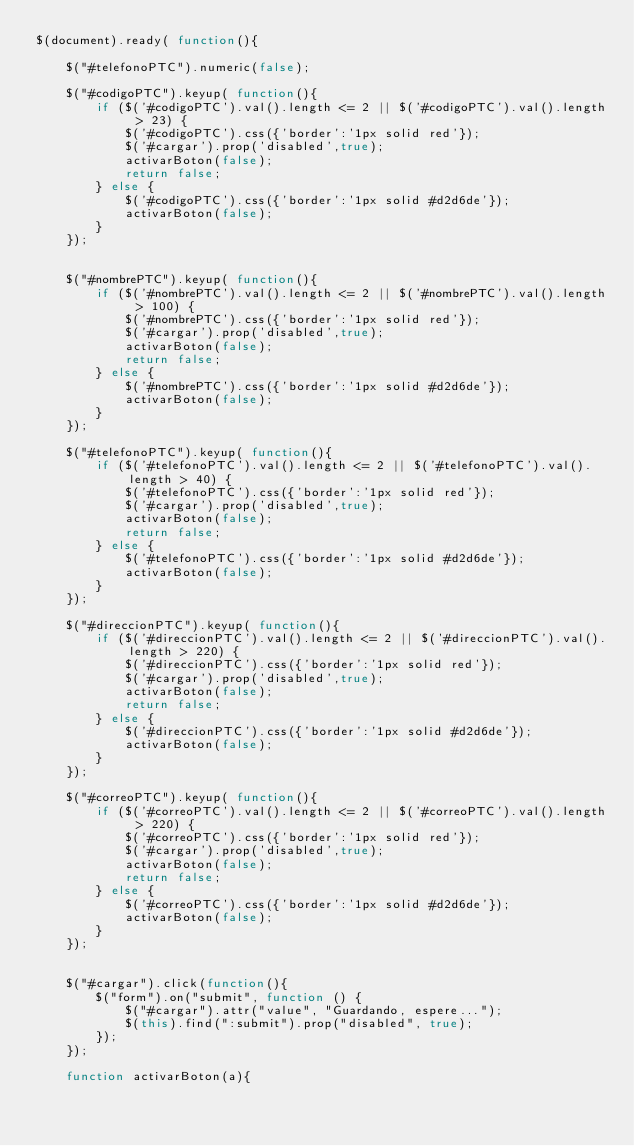Convert code to text. <code><loc_0><loc_0><loc_500><loc_500><_JavaScript_>$(document).ready( function(){

    $("#telefonoPTC").numeric(false);

    $("#codigoPTC").keyup( function(){
        if ($('#codigoPTC').val().length <= 2 || $('#codigoPTC').val().length > 23) {
            $('#codigoPTC').css({'border':'1px solid red'});
            $('#cargar').prop('disabled',true);
            activarBoton(false);
            return false;
        } else {
            $('#codigoPTC').css({'border':'1px solid #d2d6de'});
            activarBoton(false);
        }
    });


    $("#nombrePTC").keyup( function(){
        if ($('#nombrePTC').val().length <= 2 || $('#nombrePTC').val().length > 100) {
            $('#nombrePTC').css({'border':'1px solid red'});
            $('#cargar').prop('disabled',true);
            activarBoton(false);
            return false;
        } else {
            $('#nombrePTC').css({'border':'1px solid #d2d6de'});
            activarBoton(false);
        }
    });

    $("#telefonoPTC").keyup( function(){
        if ($('#telefonoPTC').val().length <= 2 || $('#telefonoPTC').val().length > 40) {
            $('#telefonoPTC').css({'border':'1px solid red'});
            $('#cargar').prop('disabled',true);
            activarBoton(false);
            return false;
        } else {
            $('#telefonoPTC').css({'border':'1px solid #d2d6de'});
            activarBoton(false);
        }
    });

    $("#direccionPTC").keyup( function(){
        if ($('#direccionPTC').val().length <= 2 || $('#direccionPTC').val().length > 220) {
            $('#direccionPTC').css({'border':'1px solid red'});
            $('#cargar').prop('disabled',true);
            activarBoton(false);
            return false;
        } else {
            $('#direccionPTC').css({'border':'1px solid #d2d6de'});
            activarBoton(false);
        }
    });

    $("#correoPTC").keyup( function(){
        if ($('#correoPTC').val().length <= 2 || $('#correoPTC').val().length > 220) {
            $('#correoPTC').css({'border':'1px solid red'});
            $('#cargar').prop('disabled',true);
            activarBoton(false);
            return false;
        } else {
            $('#correoPTC').css({'border':'1px solid #d2d6de'});
            activarBoton(false);
        }
    });


    $("#cargar").click(function(){
        $("form").on("submit", function () {
            $("#cargar").attr("value", "Guardando, espere...");
            $(this).find(":submit").prop("disabled", true);
        });
    });

    function activarBoton(a){</code> 